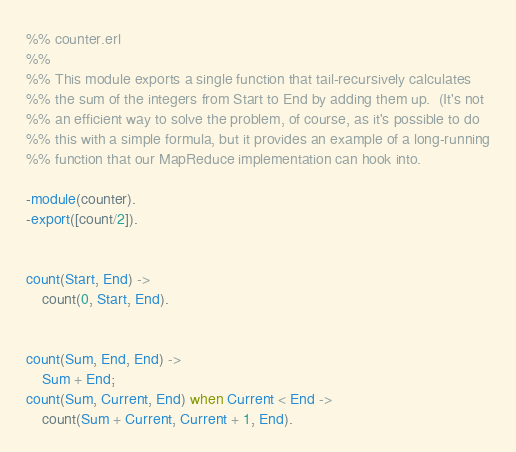<code> <loc_0><loc_0><loc_500><loc_500><_Erlang_>%% counter.erl
%% 
%% This module exports a single function that tail-recursively calculates
%% the sum of the integers from Start to End by adding them up.  (It's not
%% an efficient way to solve the problem, of course, as it's possible to do
%% this with a simple formula, but it provides an example of a long-running
%% function that our MapReduce implementation can hook into.

-module(counter).
-export([count/2]).


count(Start, End) ->
	count(0, Start, End).


count(Sum, End, End) ->
	Sum + End;
count(Sum, Current, End) when Current < End ->
	count(Sum + Current, Current + 1, End).
</code> 